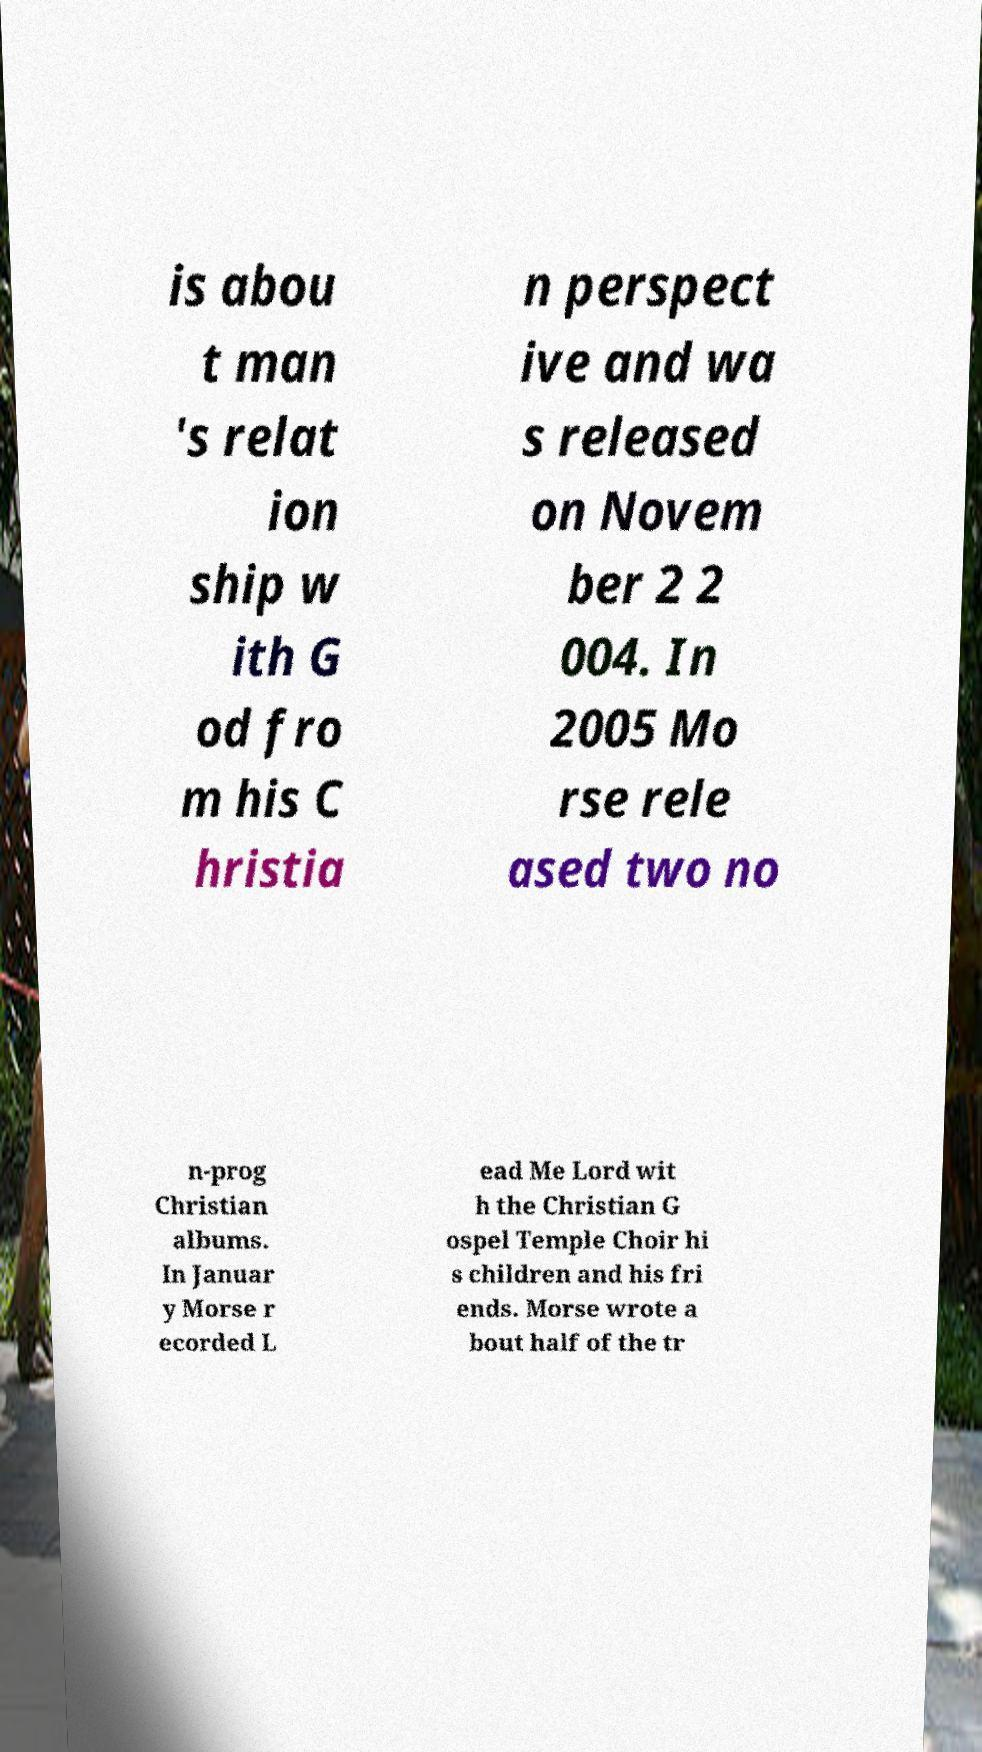For documentation purposes, I need the text within this image transcribed. Could you provide that? is abou t man 's relat ion ship w ith G od fro m his C hristia n perspect ive and wa s released on Novem ber 2 2 004. In 2005 Mo rse rele ased two no n-prog Christian albums. In Januar y Morse r ecorded L ead Me Lord wit h the Christian G ospel Temple Choir hi s children and his fri ends. Morse wrote a bout half of the tr 